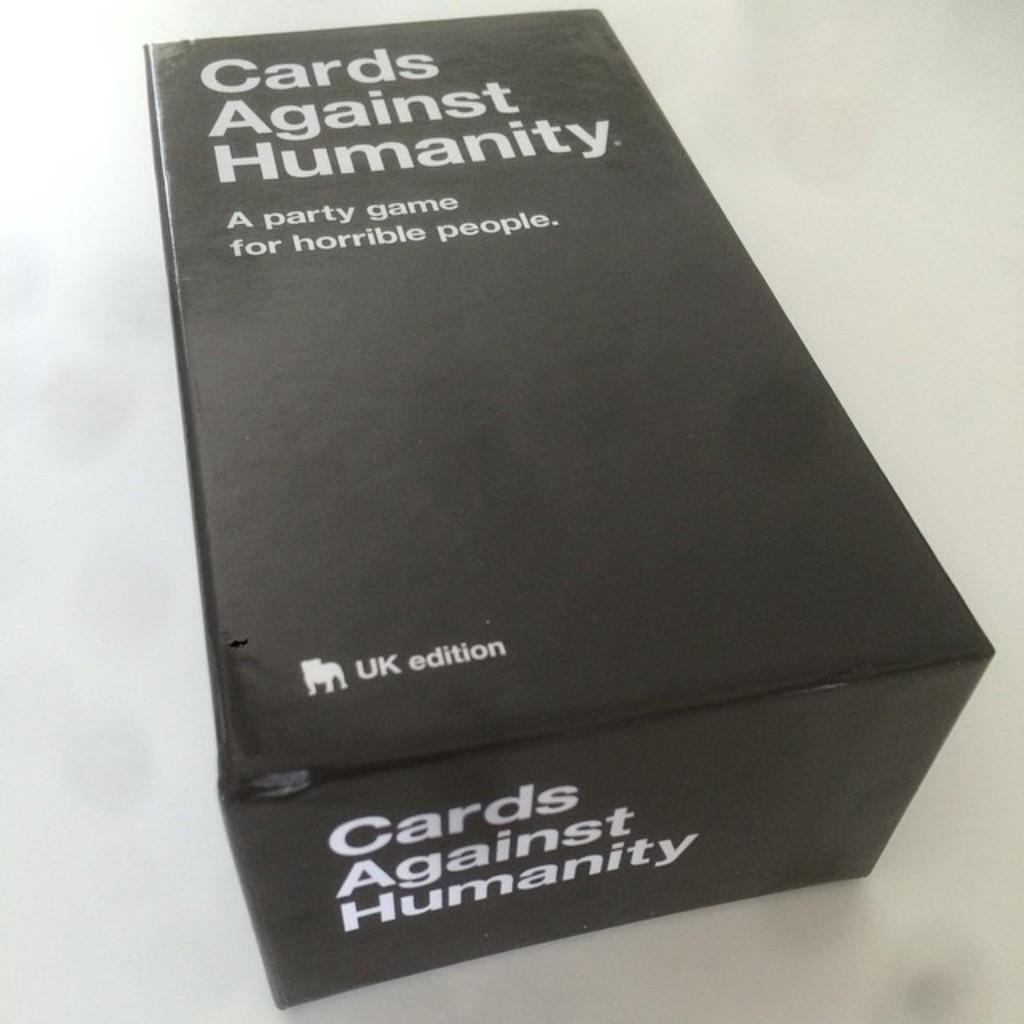Provide a one-sentence caption for the provided image. A card game is in black packaging on the table. 